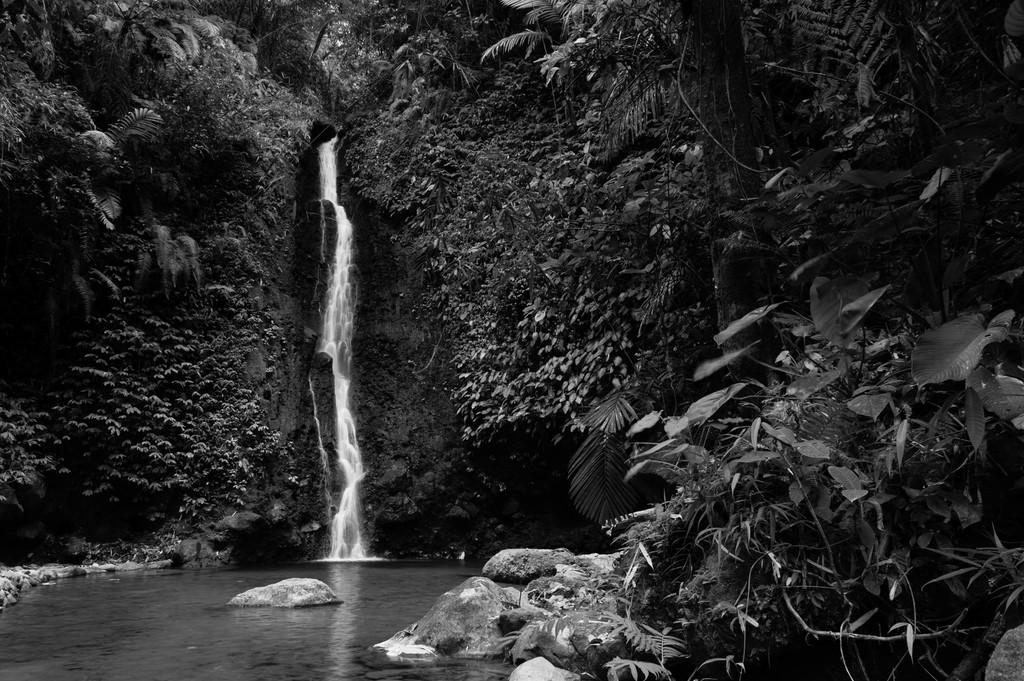What is the primary element in the image? There is water in the image. What other objects or features can be seen in the image? There are rocks and trees in the image. How is the image presented in terms of color? The image is black and white in color. What type of book can be seen on the rocks in the image? There is no book present in the image; it only features water, rocks, and trees. 